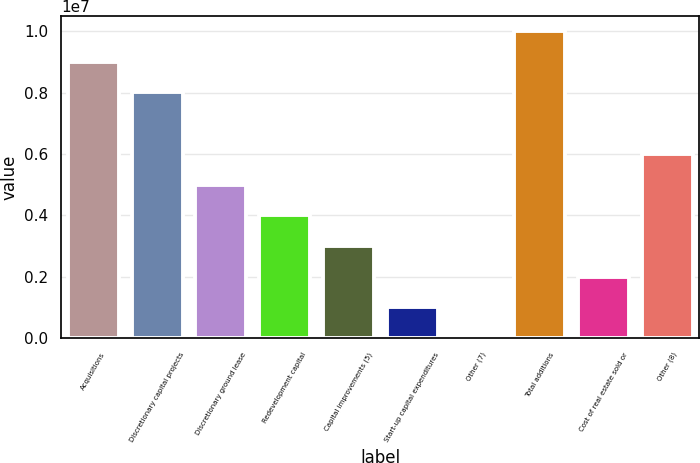<chart> <loc_0><loc_0><loc_500><loc_500><bar_chart><fcel>Acquisitions<fcel>Discretionary capital projects<fcel>Discretionary ground lease<fcel>Redevelopment capital<fcel>Capital improvements (5)<fcel>Start-up capital expenditures<fcel>Other (7)<fcel>Total additions<fcel>Cost of real estate sold or<fcel>Other (8)<nl><fcel>9.00413e+06<fcel>8.00465e+06<fcel>5.00619e+06<fcel>4.00671e+06<fcel>3.00722e+06<fcel>1.00825e+06<fcel>8764<fcel>1.00036e+07<fcel>2.00773e+06<fcel>6.00568e+06<nl></chart> 